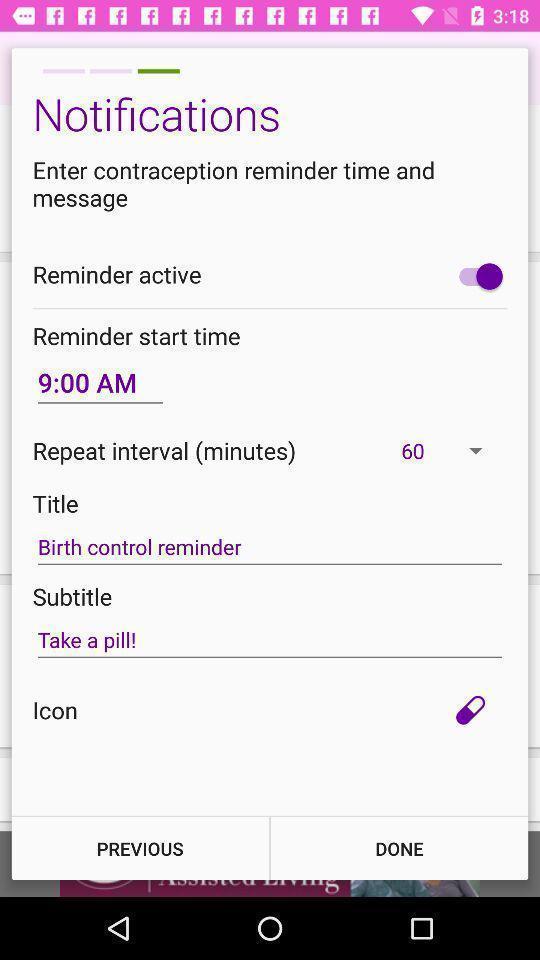What can you discern from this picture? Screen showing notification settings page. 